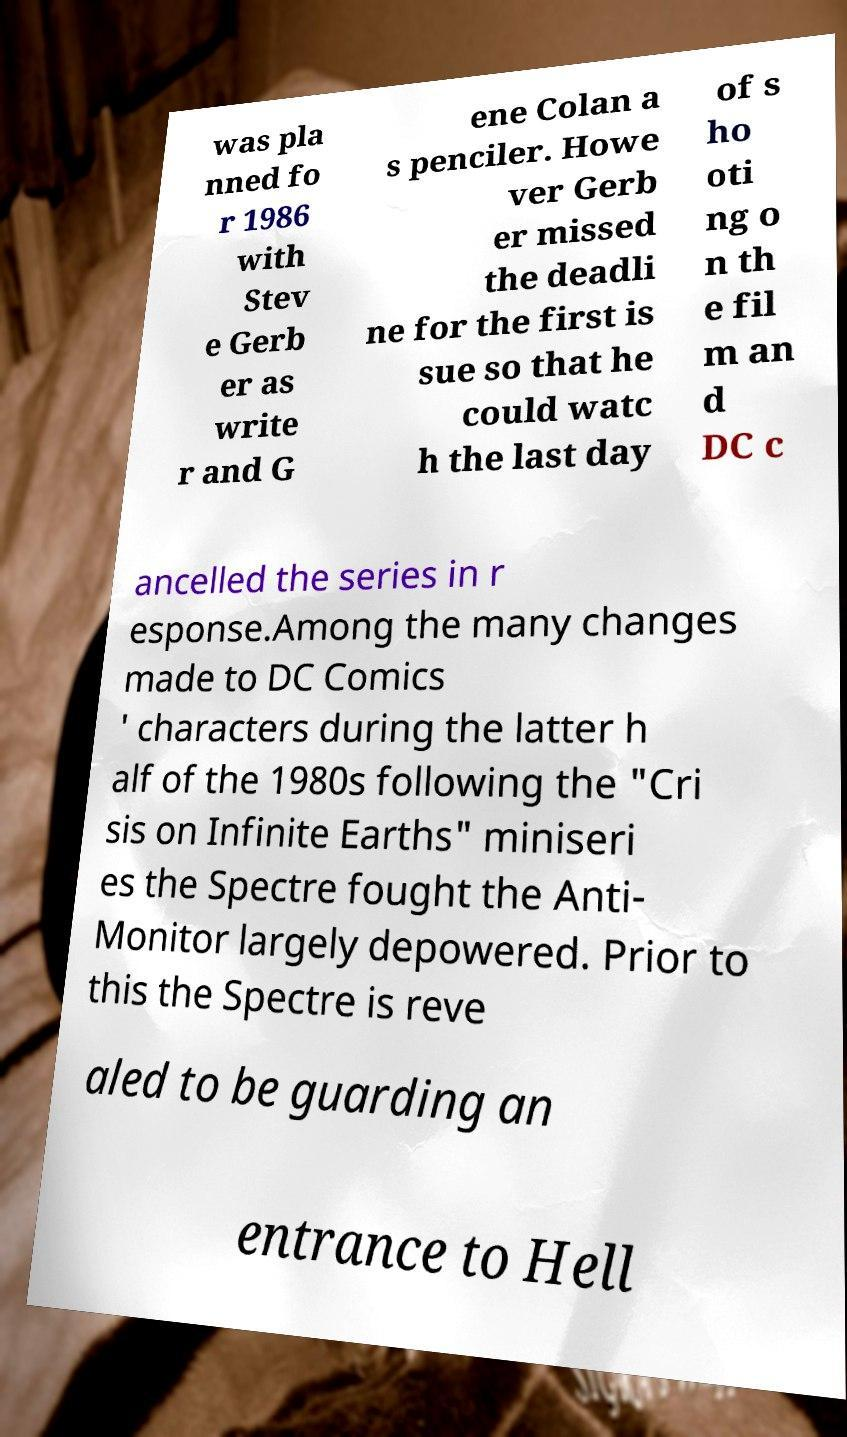I need the written content from this picture converted into text. Can you do that? was pla nned fo r 1986 with Stev e Gerb er as write r and G ene Colan a s penciler. Howe ver Gerb er missed the deadli ne for the first is sue so that he could watc h the last day of s ho oti ng o n th e fil m an d DC c ancelled the series in r esponse.Among the many changes made to DC Comics ' characters during the latter h alf of the 1980s following the "Cri sis on Infinite Earths" miniseri es the Spectre fought the Anti- Monitor largely depowered. Prior to this the Spectre is reve aled to be guarding an entrance to Hell 